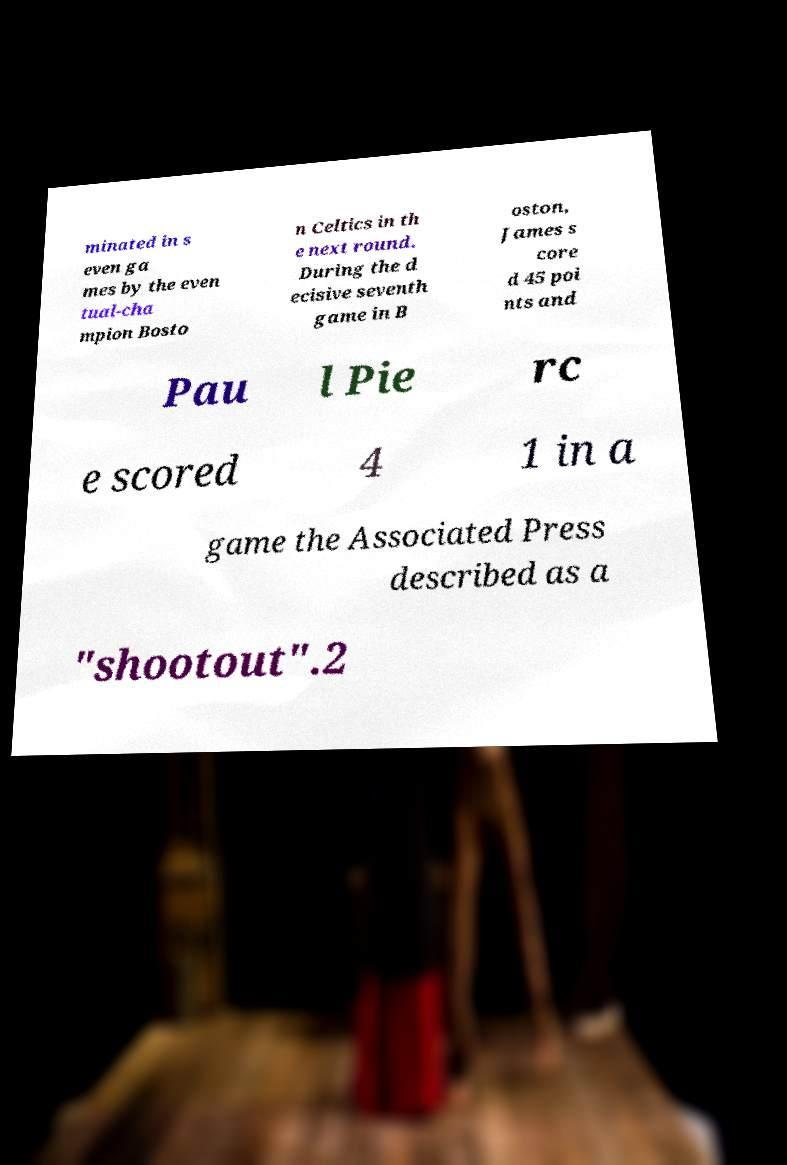Could you extract and type out the text from this image? minated in s even ga mes by the even tual-cha mpion Bosto n Celtics in th e next round. During the d ecisive seventh game in B oston, James s core d 45 poi nts and Pau l Pie rc e scored 4 1 in a game the Associated Press described as a "shootout".2 